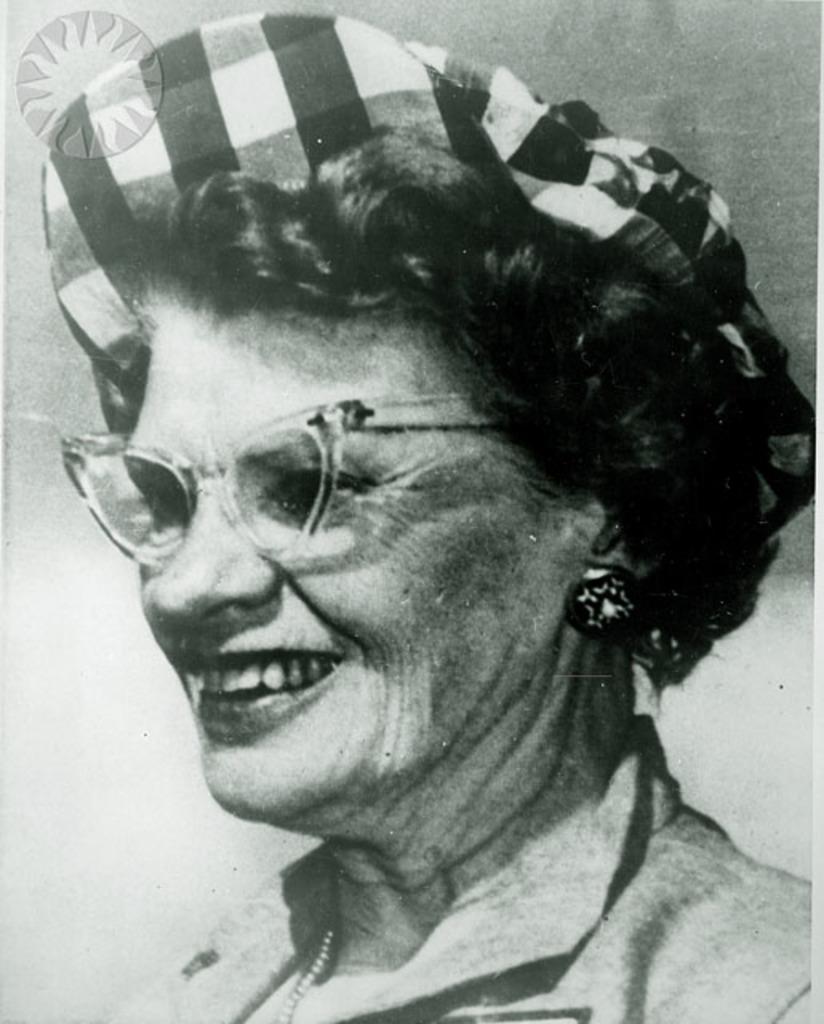Describe this image in one or two sentences. This is a black and white picture. There is a woman giving a pose in the picture. The woman is wearing a cap which is in checks format. Woman is having a short hair, it's a curly hair. she is wearing a spectacles. she is wearing a round studs and she is holding a pretty smile. We can see a chain on her neck. 